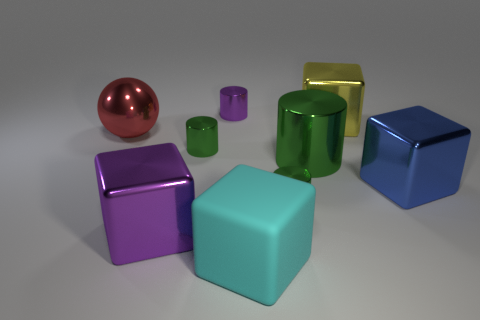Is there any other thing that has the same shape as the large red object?
Keep it short and to the point. No. How many big green things are the same shape as the big purple shiny object?
Make the answer very short. 0. Are there the same number of cyan rubber things that are behind the large purple metal thing and large yellow rubber balls?
Provide a short and direct response. Yes. The yellow object that is the same size as the blue shiny thing is what shape?
Provide a succinct answer. Cube. Is there a blue shiny object that has the same shape as the large yellow shiny object?
Ensure brevity in your answer.  Yes. There is a tiny green object that is on the right side of the purple shiny thing behind the big red metal thing; are there any purple things that are in front of it?
Keep it short and to the point. Yes. Is the number of green cylinders that are in front of the big green cylinder greater than the number of small purple cylinders that are in front of the big cyan rubber thing?
Offer a very short reply. Yes. There is a cyan block that is the same size as the purple metallic cube; what is it made of?
Offer a terse response. Rubber. How many small things are metallic cubes or purple matte spheres?
Provide a short and direct response. 0. Is the shape of the large purple metal thing the same as the large blue thing?
Keep it short and to the point. Yes. 